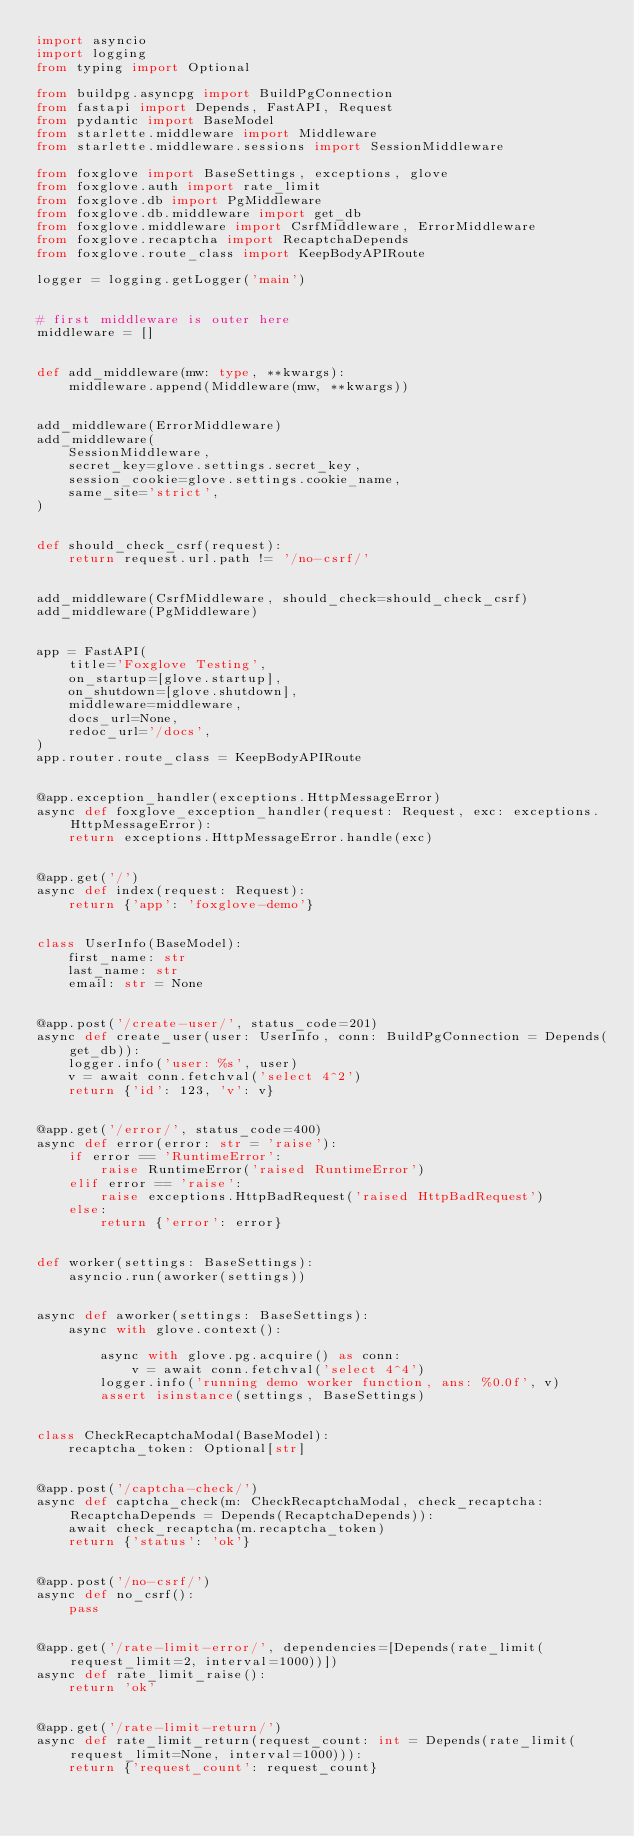Convert code to text. <code><loc_0><loc_0><loc_500><loc_500><_Python_>import asyncio
import logging
from typing import Optional

from buildpg.asyncpg import BuildPgConnection
from fastapi import Depends, FastAPI, Request
from pydantic import BaseModel
from starlette.middleware import Middleware
from starlette.middleware.sessions import SessionMiddleware

from foxglove import BaseSettings, exceptions, glove
from foxglove.auth import rate_limit
from foxglove.db import PgMiddleware
from foxglove.db.middleware import get_db
from foxglove.middleware import CsrfMiddleware, ErrorMiddleware
from foxglove.recaptcha import RecaptchaDepends
from foxglove.route_class import KeepBodyAPIRoute

logger = logging.getLogger('main')


# first middleware is outer here
middleware = []


def add_middleware(mw: type, **kwargs):
    middleware.append(Middleware(mw, **kwargs))


add_middleware(ErrorMiddleware)
add_middleware(
    SessionMiddleware,
    secret_key=glove.settings.secret_key,
    session_cookie=glove.settings.cookie_name,
    same_site='strict',
)


def should_check_csrf(request):
    return request.url.path != '/no-csrf/'


add_middleware(CsrfMiddleware, should_check=should_check_csrf)
add_middleware(PgMiddleware)


app = FastAPI(
    title='Foxglove Testing',
    on_startup=[glove.startup],
    on_shutdown=[glove.shutdown],
    middleware=middleware,
    docs_url=None,
    redoc_url='/docs',
)
app.router.route_class = KeepBodyAPIRoute


@app.exception_handler(exceptions.HttpMessageError)
async def foxglove_exception_handler(request: Request, exc: exceptions.HttpMessageError):
    return exceptions.HttpMessageError.handle(exc)


@app.get('/')
async def index(request: Request):
    return {'app': 'foxglove-demo'}


class UserInfo(BaseModel):
    first_name: str
    last_name: str
    email: str = None


@app.post('/create-user/', status_code=201)
async def create_user(user: UserInfo, conn: BuildPgConnection = Depends(get_db)):
    logger.info('user: %s', user)
    v = await conn.fetchval('select 4^2')
    return {'id': 123, 'v': v}


@app.get('/error/', status_code=400)
async def error(error: str = 'raise'):
    if error == 'RuntimeError':
        raise RuntimeError('raised RuntimeError')
    elif error == 'raise':
        raise exceptions.HttpBadRequest('raised HttpBadRequest')
    else:
        return {'error': error}


def worker(settings: BaseSettings):
    asyncio.run(aworker(settings))


async def aworker(settings: BaseSettings):
    async with glove.context():

        async with glove.pg.acquire() as conn:
            v = await conn.fetchval('select 4^4')
        logger.info('running demo worker function, ans: %0.0f', v)
        assert isinstance(settings, BaseSettings)


class CheckRecaptchaModal(BaseModel):
    recaptcha_token: Optional[str]


@app.post('/captcha-check/')
async def captcha_check(m: CheckRecaptchaModal, check_recaptcha: RecaptchaDepends = Depends(RecaptchaDepends)):
    await check_recaptcha(m.recaptcha_token)
    return {'status': 'ok'}


@app.post('/no-csrf/')
async def no_csrf():
    pass


@app.get('/rate-limit-error/', dependencies=[Depends(rate_limit(request_limit=2, interval=1000))])
async def rate_limit_raise():
    return 'ok'


@app.get('/rate-limit-return/')
async def rate_limit_return(request_count: int = Depends(rate_limit(request_limit=None, interval=1000))):
    return {'request_count': request_count}
</code> 